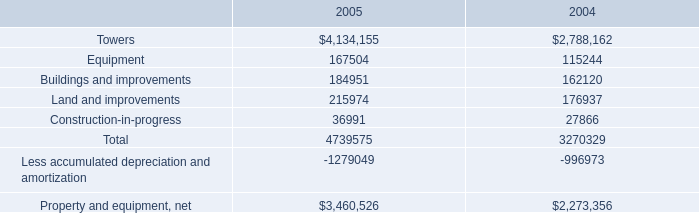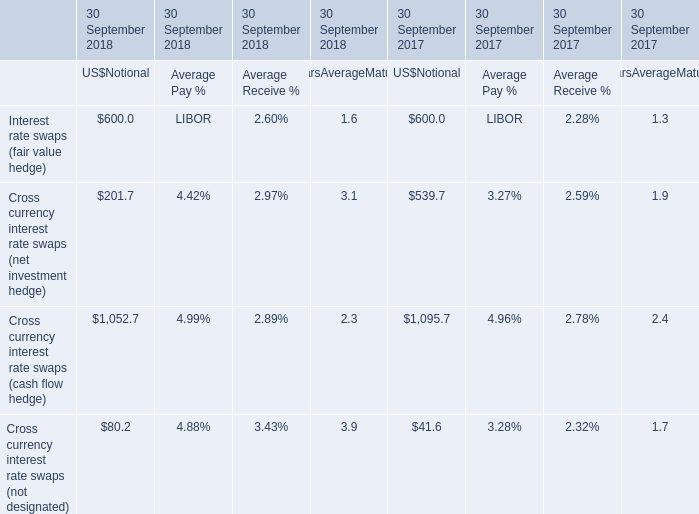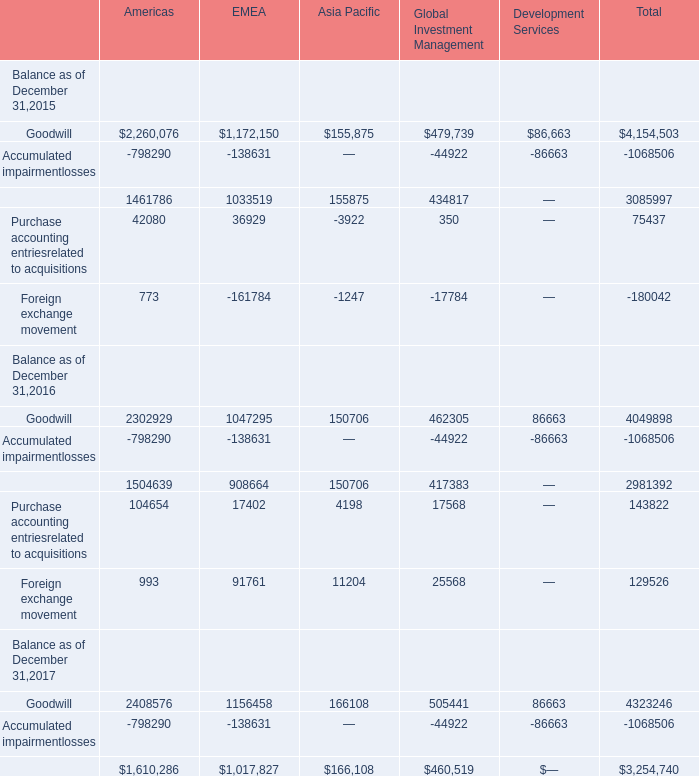If Goodwill develops with the same growth rate in 2016, what will it reach in 2017? (in million) 
Computations: (exp((1 + ((2302929 - 2260076) / 2260076)) * 2))
Answer: 2391087.99635. 